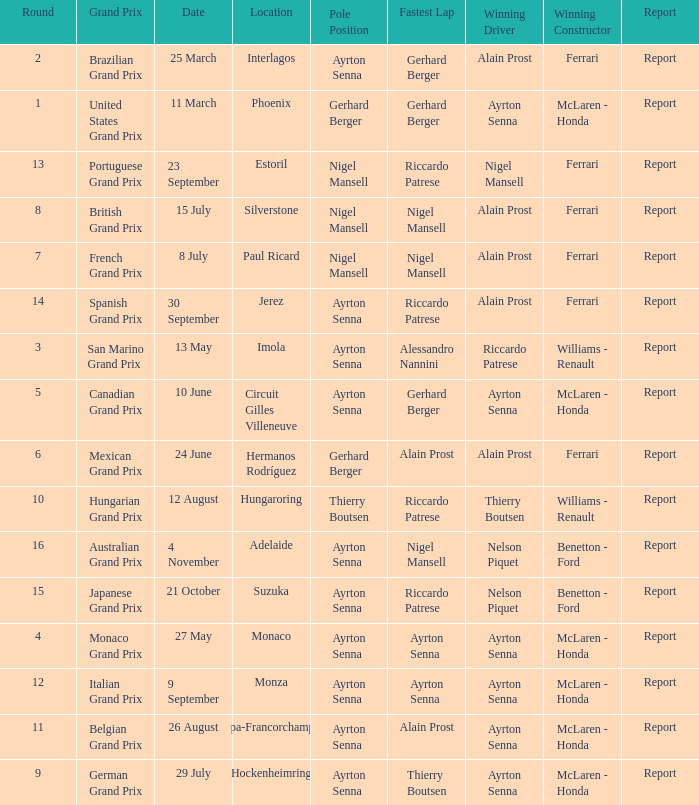What is the Pole Position for the German Grand Prix Ayrton Senna. 